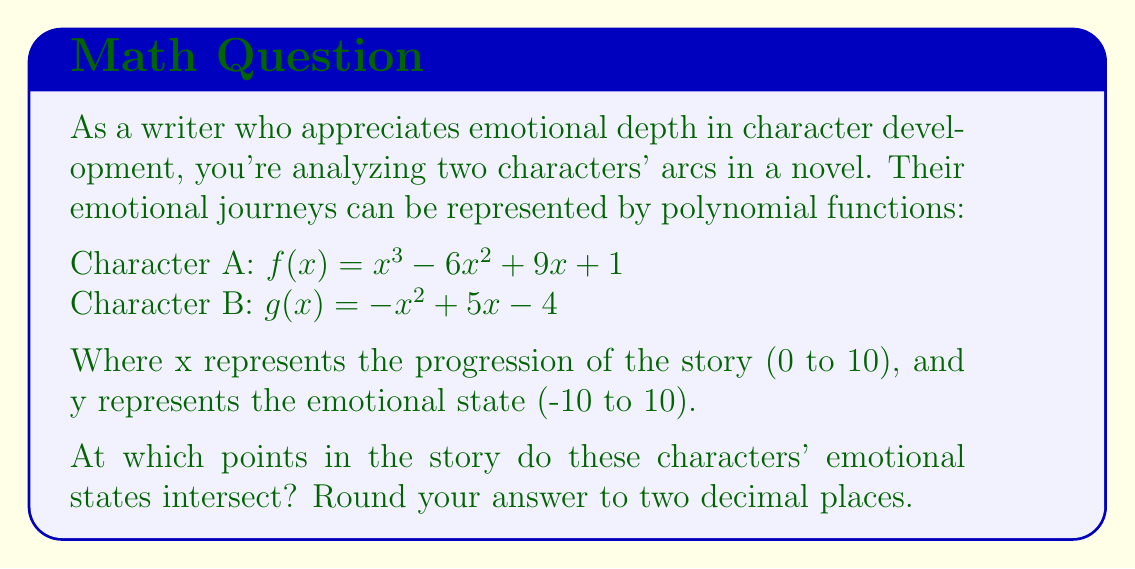Give your solution to this math problem. To find the intersecting points of these two polynomial curves, we need to solve the equation $f(x) = g(x)$:

$$x^3 - 6x^2 + 9x + 1 = -x^2 + 5x - 4$$

Rearranging the equation:

$$x^3 - 5x^2 + 4x + 5 = 0$$

This is a cubic equation. We can solve it using the following steps:

1) First, let's check if there's an obvious solution. By inspection, we can see that x = 1 is a solution:

   $1^3 - 5(1)^2 + 4(1) + 5 = 1 - 5 + 4 + 5 = 5 - 5 = 0$

2) Now we can factor out (x - 1):

   $x^3 - 5x^2 + 4x + 5 = (x - 1)(x^2 - 4x - 5)$

3) We can solve the quadratic equation $x^2 - 4x - 5 = 0$ using the quadratic formula:

   $x = \frac{-b \pm \sqrt{b^2 - 4ac}}{2a}$

   Where $a = 1$, $b = -4$, and $c = -5$

4) Plugging in these values:

   $x = \frac{4 \pm \sqrt{16 + 20}}{2} = \frac{4 \pm \sqrt{36}}{2} = \frac{4 \pm 6}{2}$

5) This gives us two more solutions:

   $x = \frac{4 + 6}{2} = 5$ and $x = \frac{4 - 6}{2} = -1$

6) However, since the story progression is from 0 to 10, we discard the negative solution.

Therefore, the characters' emotional states intersect at x = 1 and x = 5.

To find the y-coordinates, we can plug these x-values into either function:

For x = 1: $f(1) = 1^3 - 6(1)^2 + 9(1) + 1 = 1 - 6 + 9 + 1 = 5$
For x = 5: $f(5) = 5^3 - 6(5)^2 + 9(5) + 1 = 125 - 150 + 45 + 1 = 21$

However, since the emotional state is bounded between -10 and 10, the second intersection point at (5, 21) is outside our defined range.
Answer: The characters' emotional states intersect at (1.00, 5.00) within the defined range of the story. 